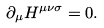<formula> <loc_0><loc_0><loc_500><loc_500>\partial _ { \mu } { H } ^ { \mu \nu \sigma } = 0 .</formula> 